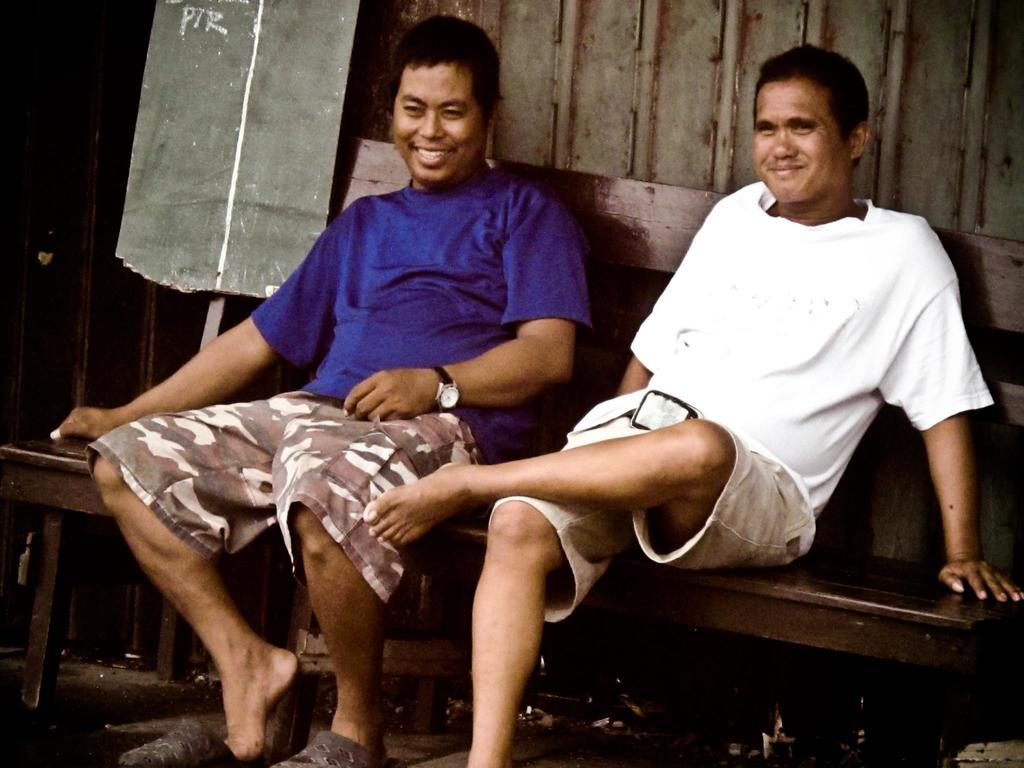How many people are in the image? There are two persons in the image. What are the persons doing in the image? The persons are sitting on a bench. What is the facial expression of the persons in the image? The persons are smiling. What can be seen in the background of the image? There is a wall in the background of the image. What type of riddle is the stranger telling the company in the image? There is no stranger or company present in the image, and therefore no such interaction can be observed. 